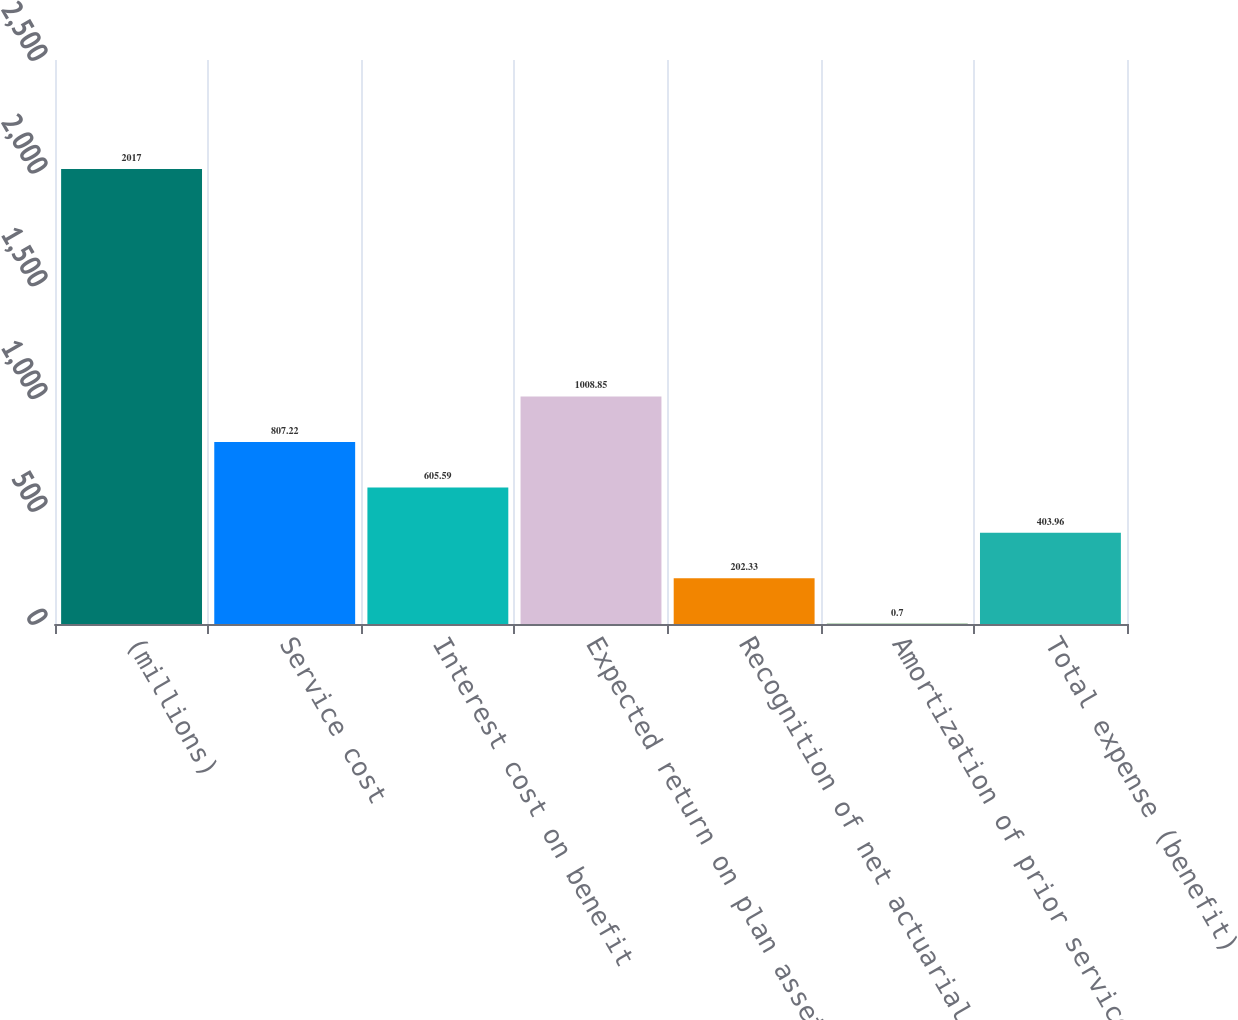Convert chart. <chart><loc_0><loc_0><loc_500><loc_500><bar_chart><fcel>(millions)<fcel>Service cost<fcel>Interest cost on benefit<fcel>Expected return on plan assets<fcel>Recognition of net actuarial<fcel>Amortization of prior service<fcel>Total expense (benefit)<nl><fcel>2017<fcel>807.22<fcel>605.59<fcel>1008.85<fcel>202.33<fcel>0.7<fcel>403.96<nl></chart> 